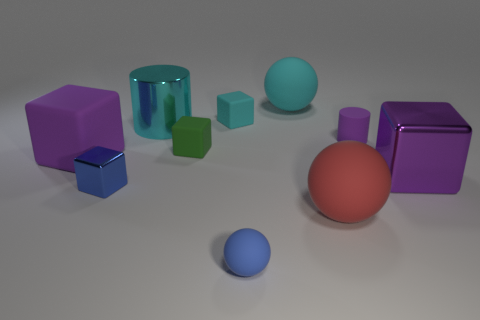What shape is the shiny thing that is the same color as the small matte cylinder?
Provide a short and direct response. Cube. Do the big matte thing that is to the left of the tiny blue ball and the matte cylinder have the same color?
Offer a very short reply. Yes. There is a small matte thing that is on the right side of the large matte ball behind the big cyan metal thing; what shape is it?
Your answer should be compact. Cylinder. What number of objects are either objects that are left of the small green block or rubber balls that are behind the tiny purple matte cylinder?
Ensure brevity in your answer.  4. There is a large purple object that is made of the same material as the large cyan sphere; what is its shape?
Your answer should be compact. Cube. Is there anything else that has the same color as the big cylinder?
Provide a succinct answer. Yes. What material is the tiny green object that is the same shape as the small cyan matte object?
Make the answer very short. Rubber. What number of other objects are there of the same size as the cyan cylinder?
Provide a short and direct response. 4. What is the blue sphere made of?
Offer a terse response. Rubber. Are there more shiny things that are on the left side of the cyan metal cylinder than big cyan metallic cylinders?
Offer a very short reply. No. 